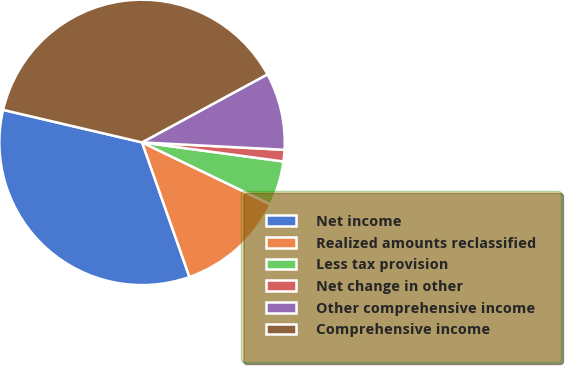Convert chart to OTSL. <chart><loc_0><loc_0><loc_500><loc_500><pie_chart><fcel>Net income<fcel>Realized amounts reclassified<fcel>Less tax provision<fcel>Net change in other<fcel>Other comprehensive income<fcel>Comprehensive income<nl><fcel>34.05%<fcel>12.45%<fcel>5.02%<fcel>1.31%<fcel>8.74%<fcel>38.43%<nl></chart> 